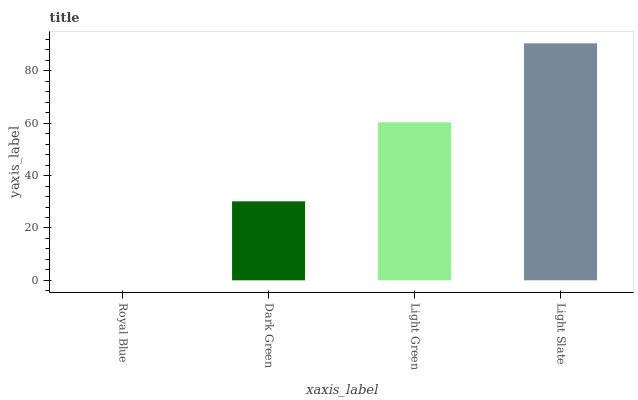Is Royal Blue the minimum?
Answer yes or no. Yes. Is Light Slate the maximum?
Answer yes or no. Yes. Is Dark Green the minimum?
Answer yes or no. No. Is Dark Green the maximum?
Answer yes or no. No. Is Dark Green greater than Royal Blue?
Answer yes or no. Yes. Is Royal Blue less than Dark Green?
Answer yes or no. Yes. Is Royal Blue greater than Dark Green?
Answer yes or no. No. Is Dark Green less than Royal Blue?
Answer yes or no. No. Is Light Green the high median?
Answer yes or no. Yes. Is Dark Green the low median?
Answer yes or no. Yes. Is Dark Green the high median?
Answer yes or no. No. Is Royal Blue the low median?
Answer yes or no. No. 